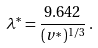<formula> <loc_0><loc_0><loc_500><loc_500>\lambda ^ { * } = \frac { 9 . 6 4 2 } { ( v ^ { * } ) ^ { 1 / 3 } } \, .</formula> 